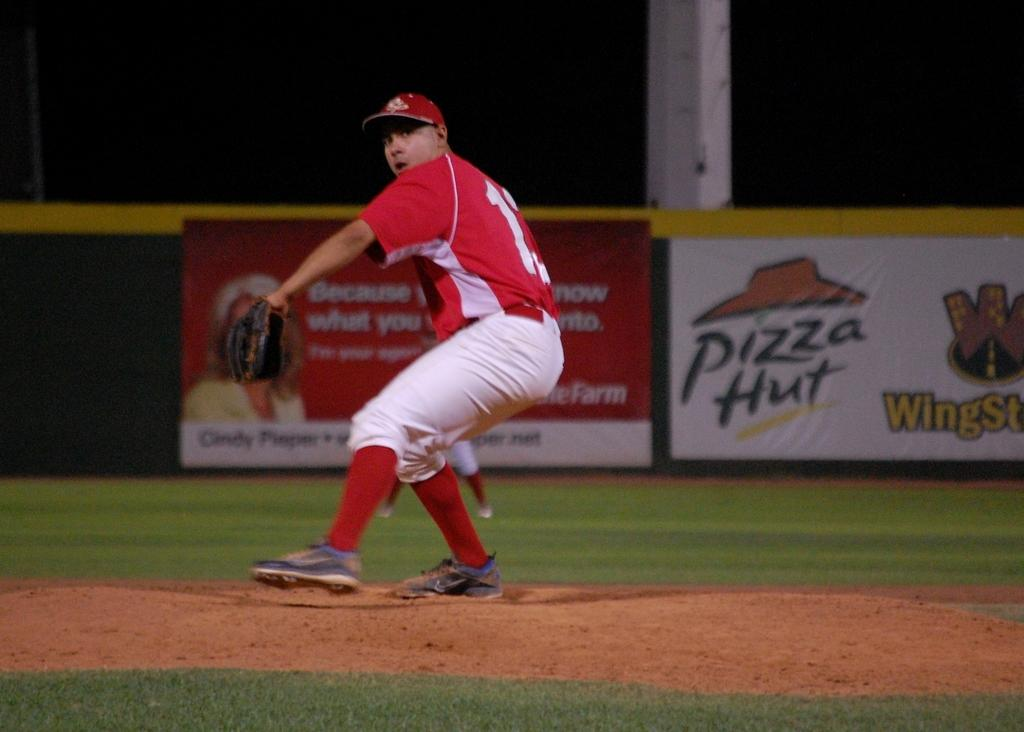<image>
Write a terse but informative summary of the picture. Baseball player pitching in front of a sign that says Pizza Hut. 